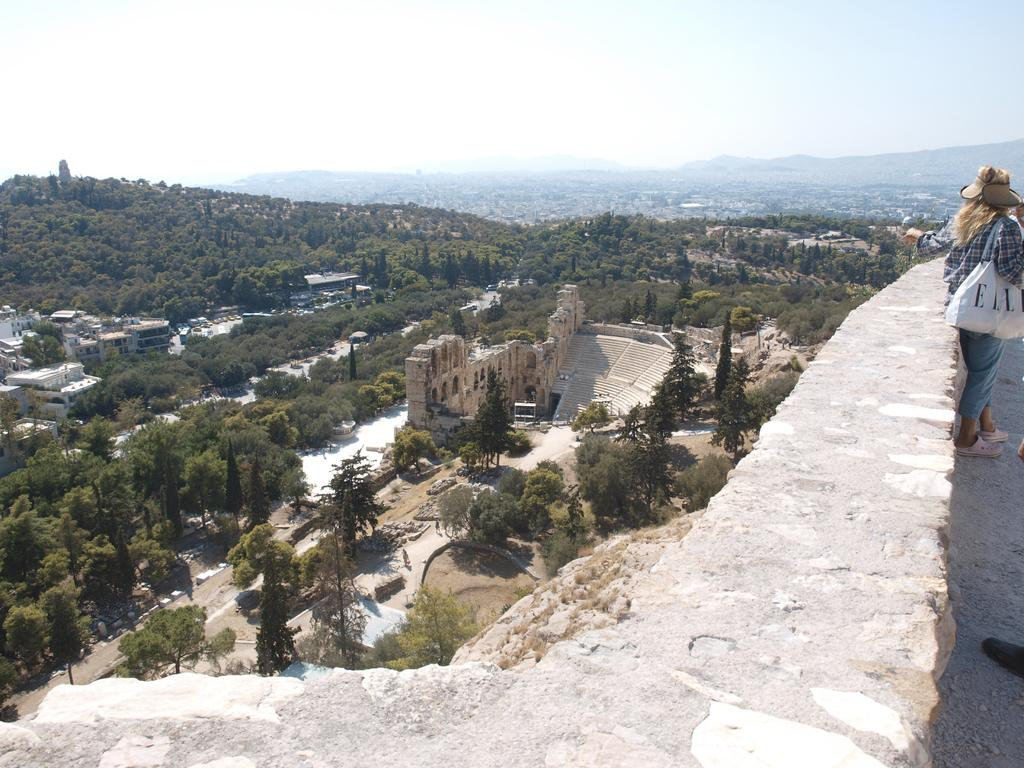Who is the person standing on the right side of the image? There is a woman standing on the right side of the image. What is the woman standing next to? The woman is standing at a wall. What can be seen in the background of the image? There are trees, an auditorium, hills, buildings, and the sky visible in the background of the image. How many moms are present in the image? There is no mention of a mom in the image, so we cannot determine the number of moms present. 